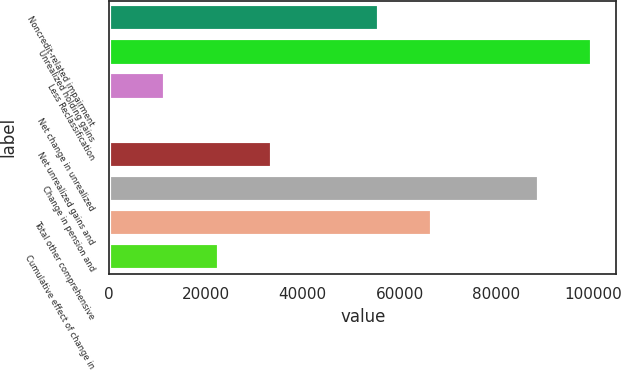<chart> <loc_0><loc_0><loc_500><loc_500><bar_chart><fcel>Noncredit-related impairment<fcel>Unrealized holding gains<fcel>Less Reclassification<fcel>Net change in unrealized<fcel>Net unrealized gains and<fcel>Change in pension and<fcel>Total other comprehensive<fcel>Cumulative effect of change in<nl><fcel>55708<fcel>99784.8<fcel>11631.2<fcel>612<fcel>33669.6<fcel>88765.6<fcel>66727.2<fcel>22650.4<nl></chart> 